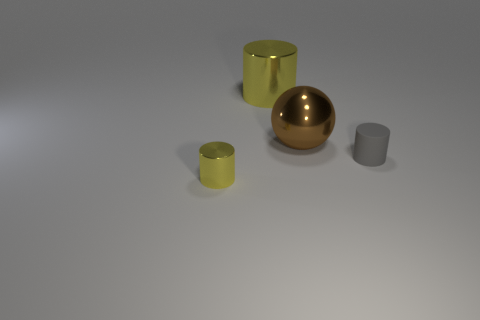Is there anything else that has the same shape as the large brown shiny thing?
Provide a succinct answer. No. Are there any other things that have the same material as the gray cylinder?
Provide a succinct answer. No. How many other small cylinders are the same color as the tiny metal cylinder?
Give a very brief answer. 0. How many things are objects that are on the right side of the tiny yellow cylinder or yellow shiny objects behind the matte cylinder?
Make the answer very short. 3. What number of tiny matte cylinders are left of the shiny cylinder behind the small gray matte cylinder?
Your answer should be very brief. 0. What is the color of the big object that is made of the same material as the big brown ball?
Your answer should be very brief. Yellow. Is there a metallic thing of the same size as the sphere?
Ensure brevity in your answer.  Yes. Are there any other small shiny objects that have the same shape as the tiny yellow metallic thing?
Offer a very short reply. No. Does the gray cylinder have the same material as the large thing in front of the big cylinder?
Your answer should be compact. No. Is there another metal cylinder of the same color as the tiny shiny cylinder?
Ensure brevity in your answer.  Yes. 